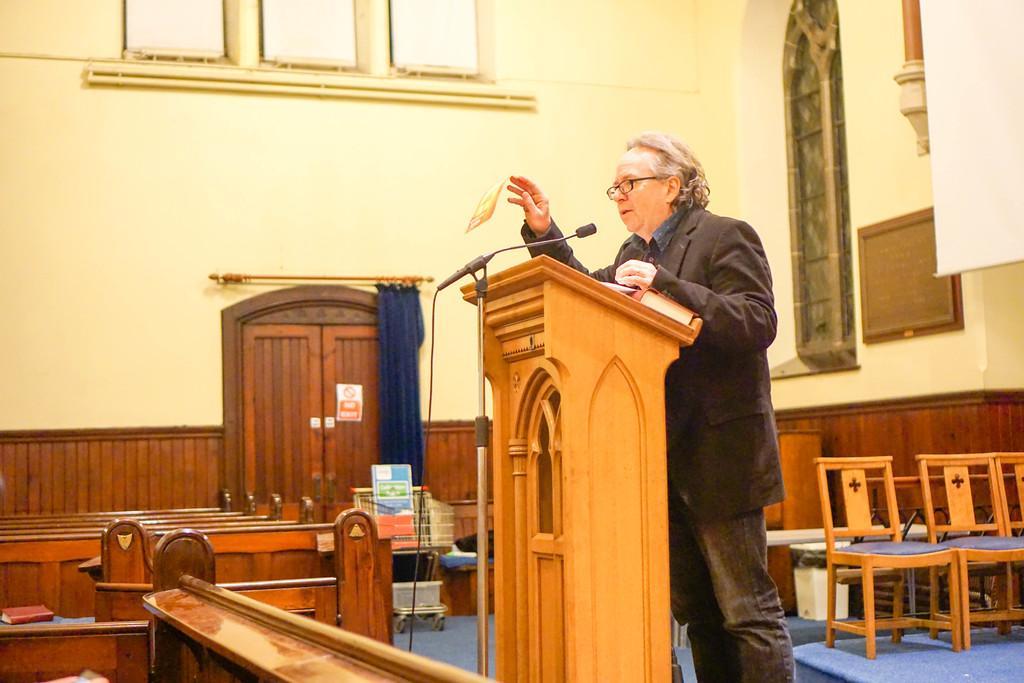Can you describe this image briefly? In this image a person a person I can see a man standing in front of a podium and there is a mike in front of him and his wearing a black color suit,back side of him there are some chairs on the floor and in front of him there is a door visible on the middle. And there are some tables kept on the right side. And there is a wall visible,and there is a curtain with blue color attached to the door on the middle 